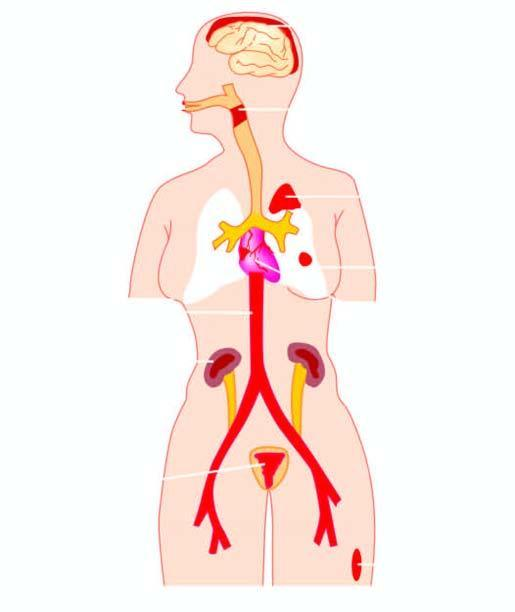s some leucocytes and red cells and a tight meshwork caused by streptococci?
Answer the question using a single word or phrase. No 